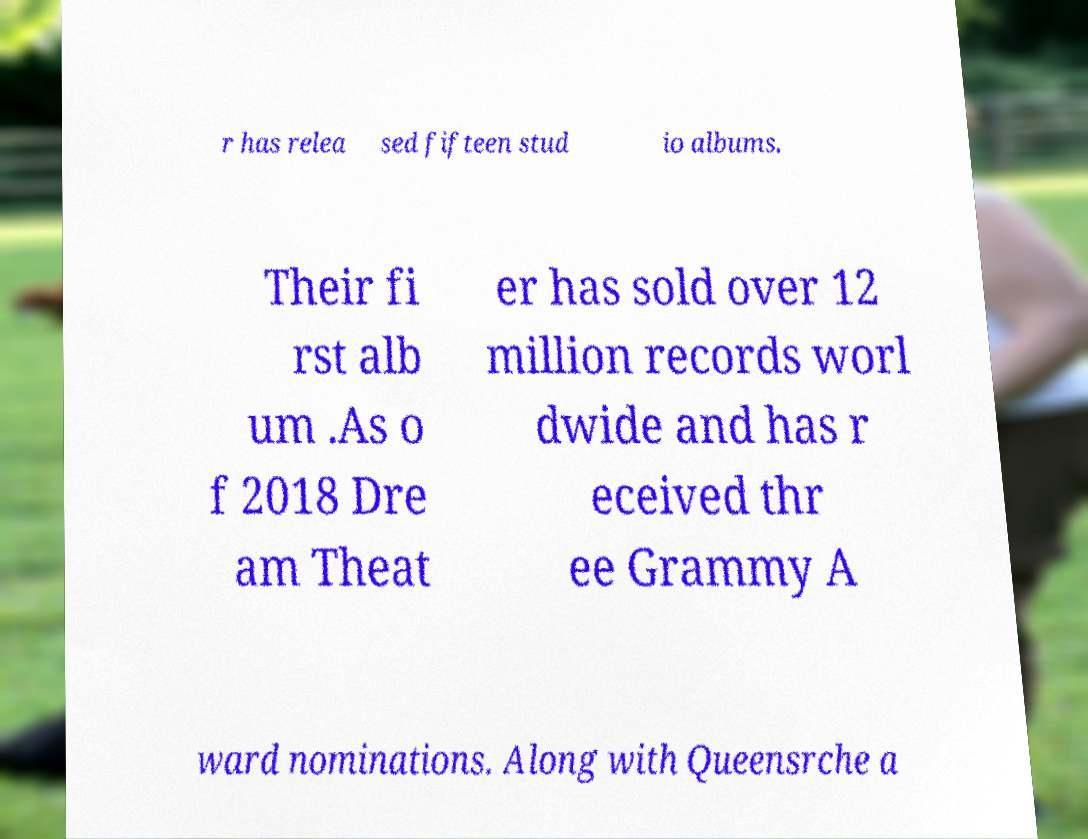I need the written content from this picture converted into text. Can you do that? r has relea sed fifteen stud io albums. Their fi rst alb um .As o f 2018 Dre am Theat er has sold over 12 million records worl dwide and has r eceived thr ee Grammy A ward nominations. Along with Queensrche a 